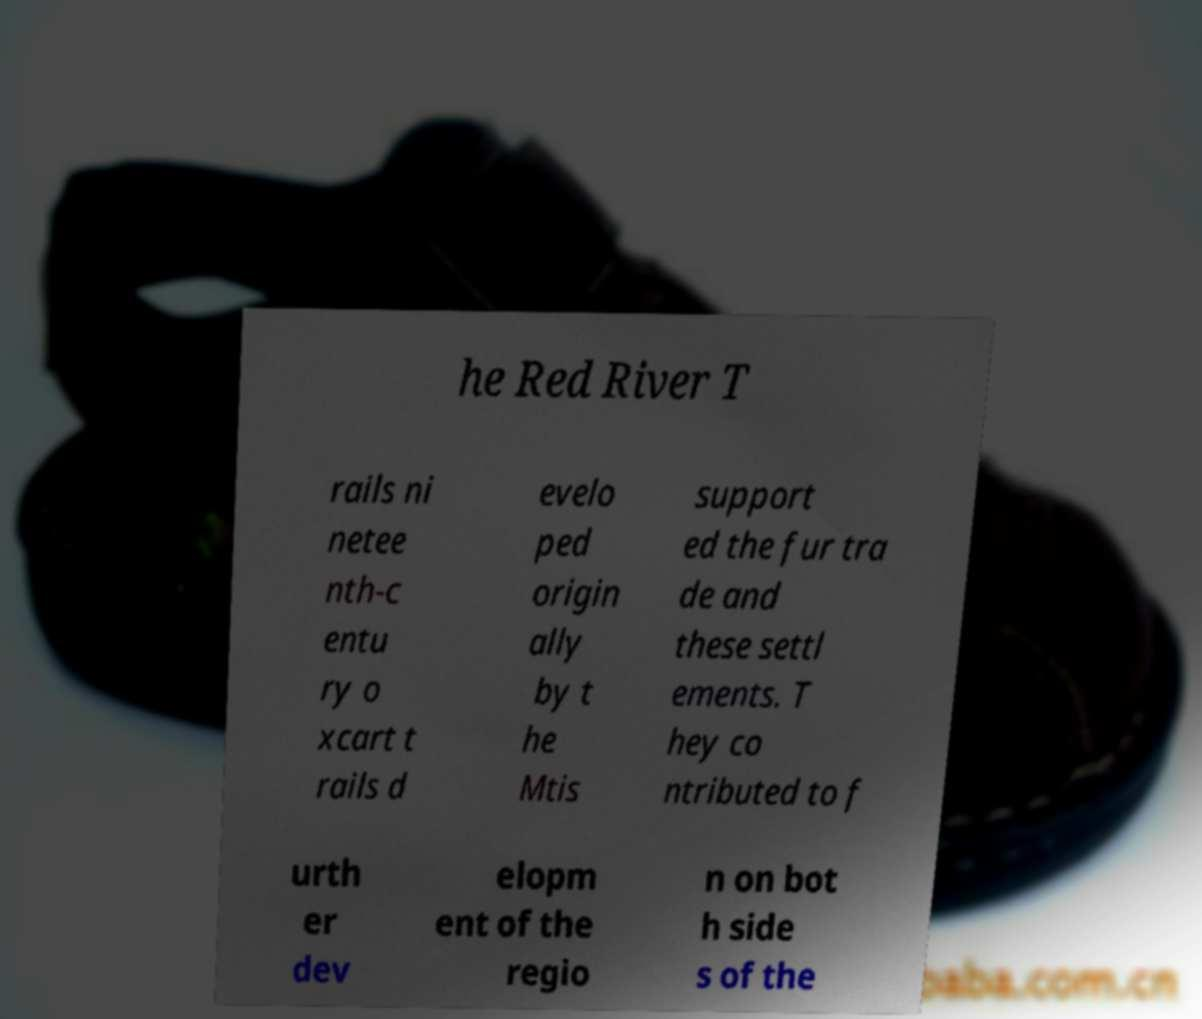For documentation purposes, I need the text within this image transcribed. Could you provide that? he Red River T rails ni netee nth-c entu ry o xcart t rails d evelo ped origin ally by t he Mtis support ed the fur tra de and these settl ements. T hey co ntributed to f urth er dev elopm ent of the regio n on bot h side s of the 